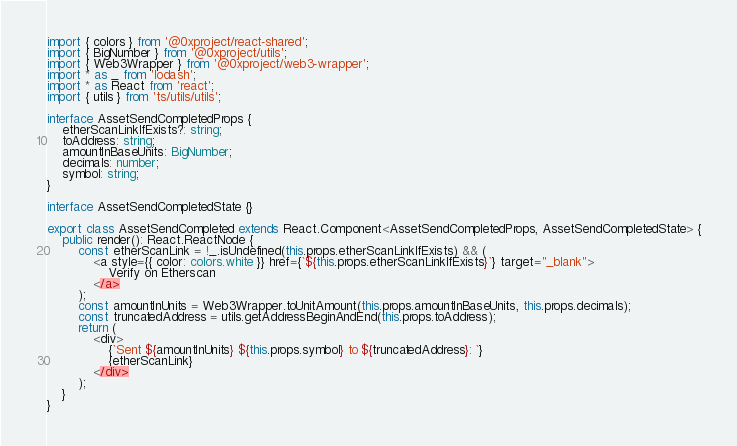Convert code to text. <code><loc_0><loc_0><loc_500><loc_500><_TypeScript_>import { colors } from '@0xproject/react-shared';
import { BigNumber } from '@0xproject/utils';
import { Web3Wrapper } from '@0xproject/web3-wrapper';
import * as _ from 'lodash';
import * as React from 'react';
import { utils } from 'ts/utils/utils';

interface AssetSendCompletedProps {
    etherScanLinkIfExists?: string;
    toAddress: string;
    amountInBaseUnits: BigNumber;
    decimals: number;
    symbol: string;
}

interface AssetSendCompletedState {}

export class AssetSendCompleted extends React.Component<AssetSendCompletedProps, AssetSendCompletedState> {
    public render(): React.ReactNode {
        const etherScanLink = !_.isUndefined(this.props.etherScanLinkIfExists) && (
            <a style={{ color: colors.white }} href={`${this.props.etherScanLinkIfExists}`} target="_blank">
                Verify on Etherscan
            </a>
        );
        const amountInUnits = Web3Wrapper.toUnitAmount(this.props.amountInBaseUnits, this.props.decimals);
        const truncatedAddress = utils.getAddressBeginAndEnd(this.props.toAddress);
        return (
            <div>
                {`Sent ${amountInUnits} ${this.props.symbol} to ${truncatedAddress}: `}
                {etherScanLink}
            </div>
        );
    }
}
</code> 